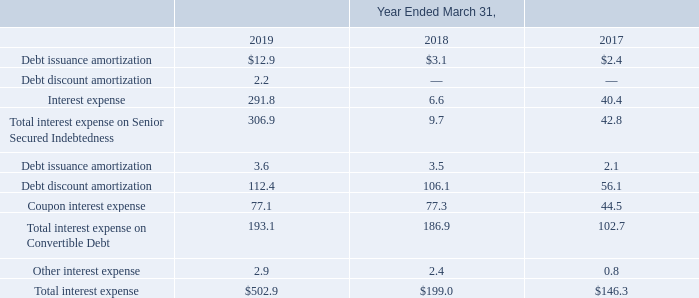Interest expense includes the following (in millions):
The remaining period over which the unamortized debt discount will be recognized as non-cash interest expense is 7.88 years, 5.88 years, and 17.88 years for the 2017 Senior Convertible Debt, 2015 Senior Convertible Debt and 2017 Junior Convertible Debt, respectively.
In November 2017, the Company called for redemption $14.6 million in principal value of the remaining outstanding 2007 Junior Subordinated Convertible Debt (2007 Junior Convertible Debt) with an effective redemption date of December 15, 2017 for which substantially all holders submitted requests to convert. Prior to the call, conversion requests were received in both the second and third quarters of fiscal 2018. Total conversions for fiscal 2018 were for a principal amount of $32.5 million for which the Company settled the principal amount in cash and issued 0.5 million shares of its common stock in respect of the conversion value in excess of the principal amount for the conversions occurring prior to the redemption notice and $41.0  of redemption. A loss on total conversions was recorded for $2.2 million.
In June 2017, the Company exchanged, in privately negotiated transactions, $111.3 million aggregate principal amount of its 2007 Junior Convertible Debt for (i) $111.3 million principal amount of 2017 Junior Convertible Debt with a market value of $119.3 million plus (ii) the issuance of 3.2 million shares of the Company's common stock with a value of $254.6 million, of which $56.3 million was allocated to the fair value of the liability and $321.1 million was allocated to the reacquisition of the equity component for total consideration of $374.0 million. The transaction resulted in a loss on settlement of the 2007 Junior Convertible Debt of approximately $13.8 million, which represented the difference between the fair value of the liability component at time of repurchase and the sum of the carrying values of the debt component and any unamortized debt issuance costs. The debt discount on the new 2017 Junior Convertible Debt was the difference between the par value and the fair value of the debt resulting in a debt discount of $55.1 million which will be amortized to interest expense using the effective interest method over the term of the debt.
In February 2017, the Company issued the 2017 Senior Convertible Debt and 2017 Junior Convertible Debt for net proceeds of $2.04 billion and $567.7 million, respectively. In connection with the issuance of these instruments, the Company incurred issuance costs of $33.7 million, of which $17.8 million and $3.4 million was recorded as convertible debt issuance costs related to the 2017 Senior Convertible Debt and 2017 Junior Convertible Debt, respectively, and will be amortized using the effective interest method over the term of the debt. The balance of $12.5 million in fees was recorded to equity. Interest on both instruments is payable semi-annually on February 15 and August 15 of each year.
In February 2015, the Company issued the 2015 Senior Convertible Debt for net proceeds of approximately $1.69 billion. In connection with the issuance, the Company incurred issuance costs of $30.3 million, of which $20.4 million was recorded as debt issuance costs and will be amortized using the effective interest method over the term of the debt. The balance of $9.9 million was recorded to equity.
The Company utilized the proceeds from the issuances of the 2017 Senior Convertible Debt, 2017 Junior Convertible Debt, and 2015 Senior Convertible Debt to reduce amounts borrowed under its Credit Facility and to settle a portion of the 2007 Junior Convertible Debt in privately negotiated transactions. In February 2017 and February 2015, the Company settled $431.3 million and $575.0 million, respectively, in aggregate principal of its 2007 Junior Convertible Debt. The February 2015 repurchase consisted solely of cash. In February 2017, the Company used cash of $431.3 million and an aggregate of 12.0 million in shares of the Company's common stock valued at $862.7 million for total consideration of $1.29 billion to repurchase $431.3 million of the 2007 Junior Convertible Debt, of which $188.0 million was allocated to the liability component and $1.11 billion was allocated to the equity component. In addition, in February 2017, there was an inducement fee of $5.0 million which was recorded in the consolidated statements of income in loss on settlement of debt. The consideration transferred in February 2015 was $1.13 billion, of which $238.3 million was allocated to the liability component and $896.3 million was allocated to the equity component. In the case of both settlements of the 2007 Junior Convertible Debt, the consideration was allocated to the liability and equity components using the equivalent rate that reflected the borrowing rate for a similar nonconvertible debt prior to the retirement. The transactions resulted in a loss on settlement of debt of approximately $43.9 million and $50.6 million in fiscal 2017 and fiscal 2015, respectively, which represented, in each case, the difference between the fair value of the liability component at time of repurchase and the sum of the carrying values of the debt component and any unamortized debt issuance costs.
What was the remaining period over which the unamortized debt discount will be recognized as non-cash interest expense for the 2017 Senior Convertible Debt? 7.88 years. What was the Debt issuance amortization in 2018?
Answer scale should be: million. 3.1. Which years does the table provide information for the company's interest expense? 2019, 2018, 2017. What was the change in Other interest expense between 2017 and 2018?
Answer scale should be: million. 2.4-0.8
Answer: 1.6. How many years did Debt discount amortization exceed $100 million? 2019##2018
Answer: 2. What was the percentage change in total interest expense between 2018 and 2019?
Answer scale should be: percent. (502.9-199.0)/199.0
Answer: 152.71. 